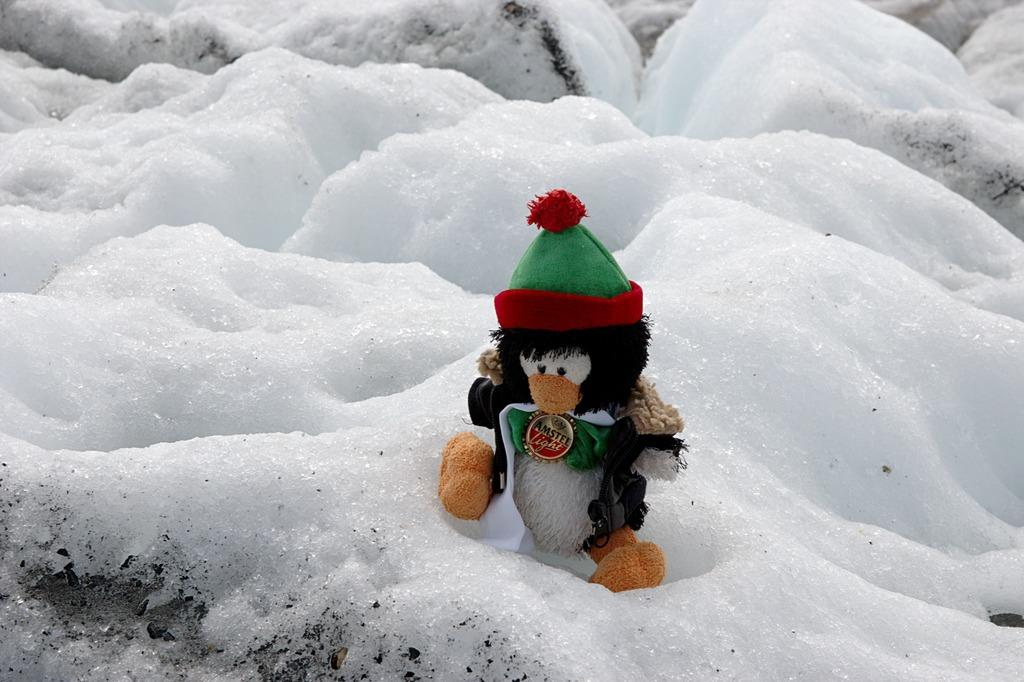What is the main subject in the image? There is a monkey doll in the image. Where is the monkey doll located in the image? The monkey doll is in the front of the image. What type of weather is suggested by the presence of snow in the image? The presence of snow suggests cold weather in the image. What type of carriage is being pulled by the monkey doll in the image? There is no carriage present in the image; it only features a monkey doll. What advice does the monkey doll give to the viewer in the image? The monkey doll does not give any advice in the image, as it is an inanimate object. 